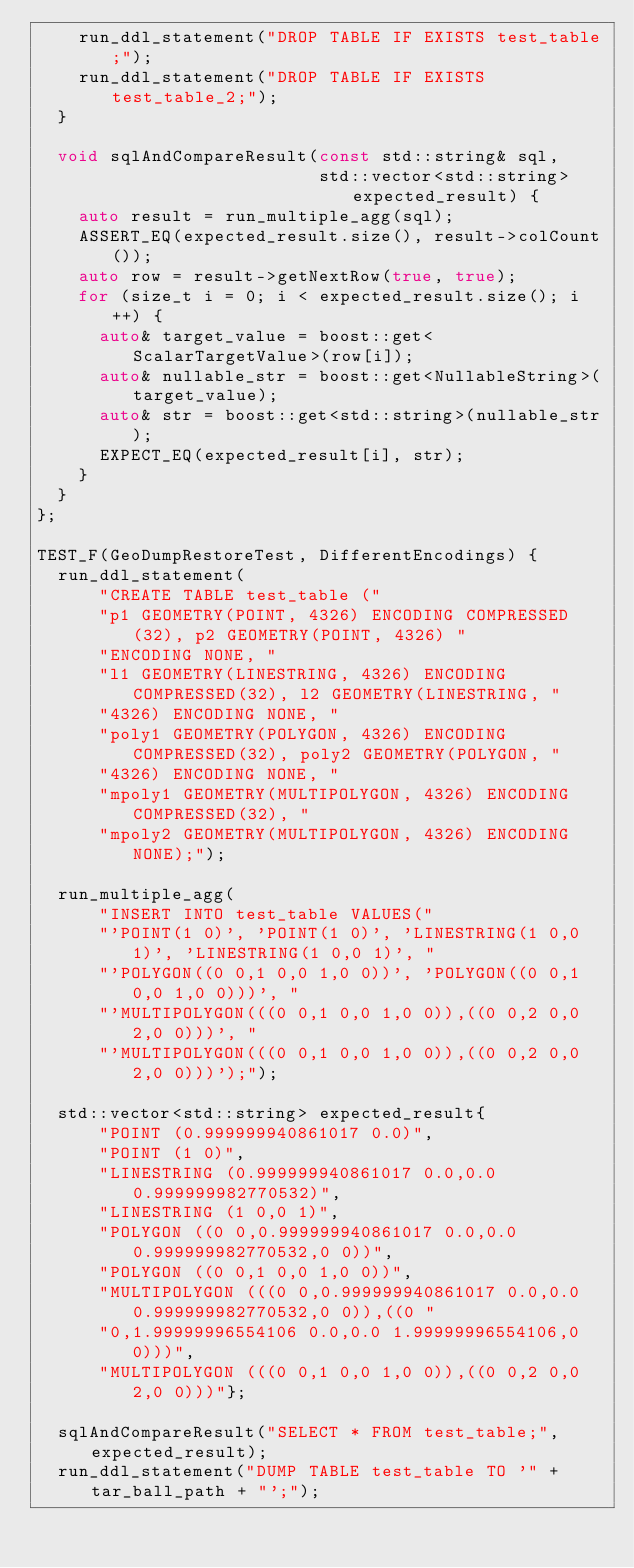<code> <loc_0><loc_0><loc_500><loc_500><_C++_>    run_ddl_statement("DROP TABLE IF EXISTS test_table;");
    run_ddl_statement("DROP TABLE IF EXISTS test_table_2;");
  }

  void sqlAndCompareResult(const std::string& sql,
                           std::vector<std::string> expected_result) {
    auto result = run_multiple_agg(sql);
    ASSERT_EQ(expected_result.size(), result->colCount());
    auto row = result->getNextRow(true, true);
    for (size_t i = 0; i < expected_result.size(); i++) {
      auto& target_value = boost::get<ScalarTargetValue>(row[i]);
      auto& nullable_str = boost::get<NullableString>(target_value);
      auto& str = boost::get<std::string>(nullable_str);
      EXPECT_EQ(expected_result[i], str);
    }
  }
};

TEST_F(GeoDumpRestoreTest, DifferentEncodings) {
  run_ddl_statement(
      "CREATE TABLE test_table ("
      "p1 GEOMETRY(POINT, 4326) ENCODING COMPRESSED(32), p2 GEOMETRY(POINT, 4326) "
      "ENCODING NONE, "
      "l1 GEOMETRY(LINESTRING, 4326) ENCODING COMPRESSED(32), l2 GEOMETRY(LINESTRING, "
      "4326) ENCODING NONE, "
      "poly1 GEOMETRY(POLYGON, 4326) ENCODING COMPRESSED(32), poly2 GEOMETRY(POLYGON, "
      "4326) ENCODING NONE, "
      "mpoly1 GEOMETRY(MULTIPOLYGON, 4326) ENCODING COMPRESSED(32), "
      "mpoly2 GEOMETRY(MULTIPOLYGON, 4326) ENCODING NONE);");

  run_multiple_agg(
      "INSERT INTO test_table VALUES("
      "'POINT(1 0)', 'POINT(1 0)', 'LINESTRING(1 0,0 1)', 'LINESTRING(1 0,0 1)', "
      "'POLYGON((0 0,1 0,0 1,0 0))', 'POLYGON((0 0,1 0,0 1,0 0)))', "
      "'MULTIPOLYGON(((0 0,1 0,0 1,0 0)),((0 0,2 0,0 2,0 0)))', "
      "'MULTIPOLYGON(((0 0,1 0,0 1,0 0)),((0 0,2 0,0 2,0 0)))');");

  std::vector<std::string> expected_result{
      "POINT (0.999999940861017 0.0)",
      "POINT (1 0)",
      "LINESTRING (0.999999940861017 0.0,0.0 0.999999982770532)",
      "LINESTRING (1 0,0 1)",
      "POLYGON ((0 0,0.999999940861017 0.0,0.0 0.999999982770532,0 0))",
      "POLYGON ((0 0,1 0,0 1,0 0))",
      "MULTIPOLYGON (((0 0,0.999999940861017 0.0,0.0 0.999999982770532,0 0)),((0 "
      "0,1.99999996554106 0.0,0.0 1.99999996554106,0 0)))",
      "MULTIPOLYGON (((0 0,1 0,0 1,0 0)),((0 0,2 0,0 2,0 0)))"};

  sqlAndCompareResult("SELECT * FROM test_table;", expected_result);
  run_ddl_statement("DUMP TABLE test_table TO '" + tar_ball_path + "';");</code> 